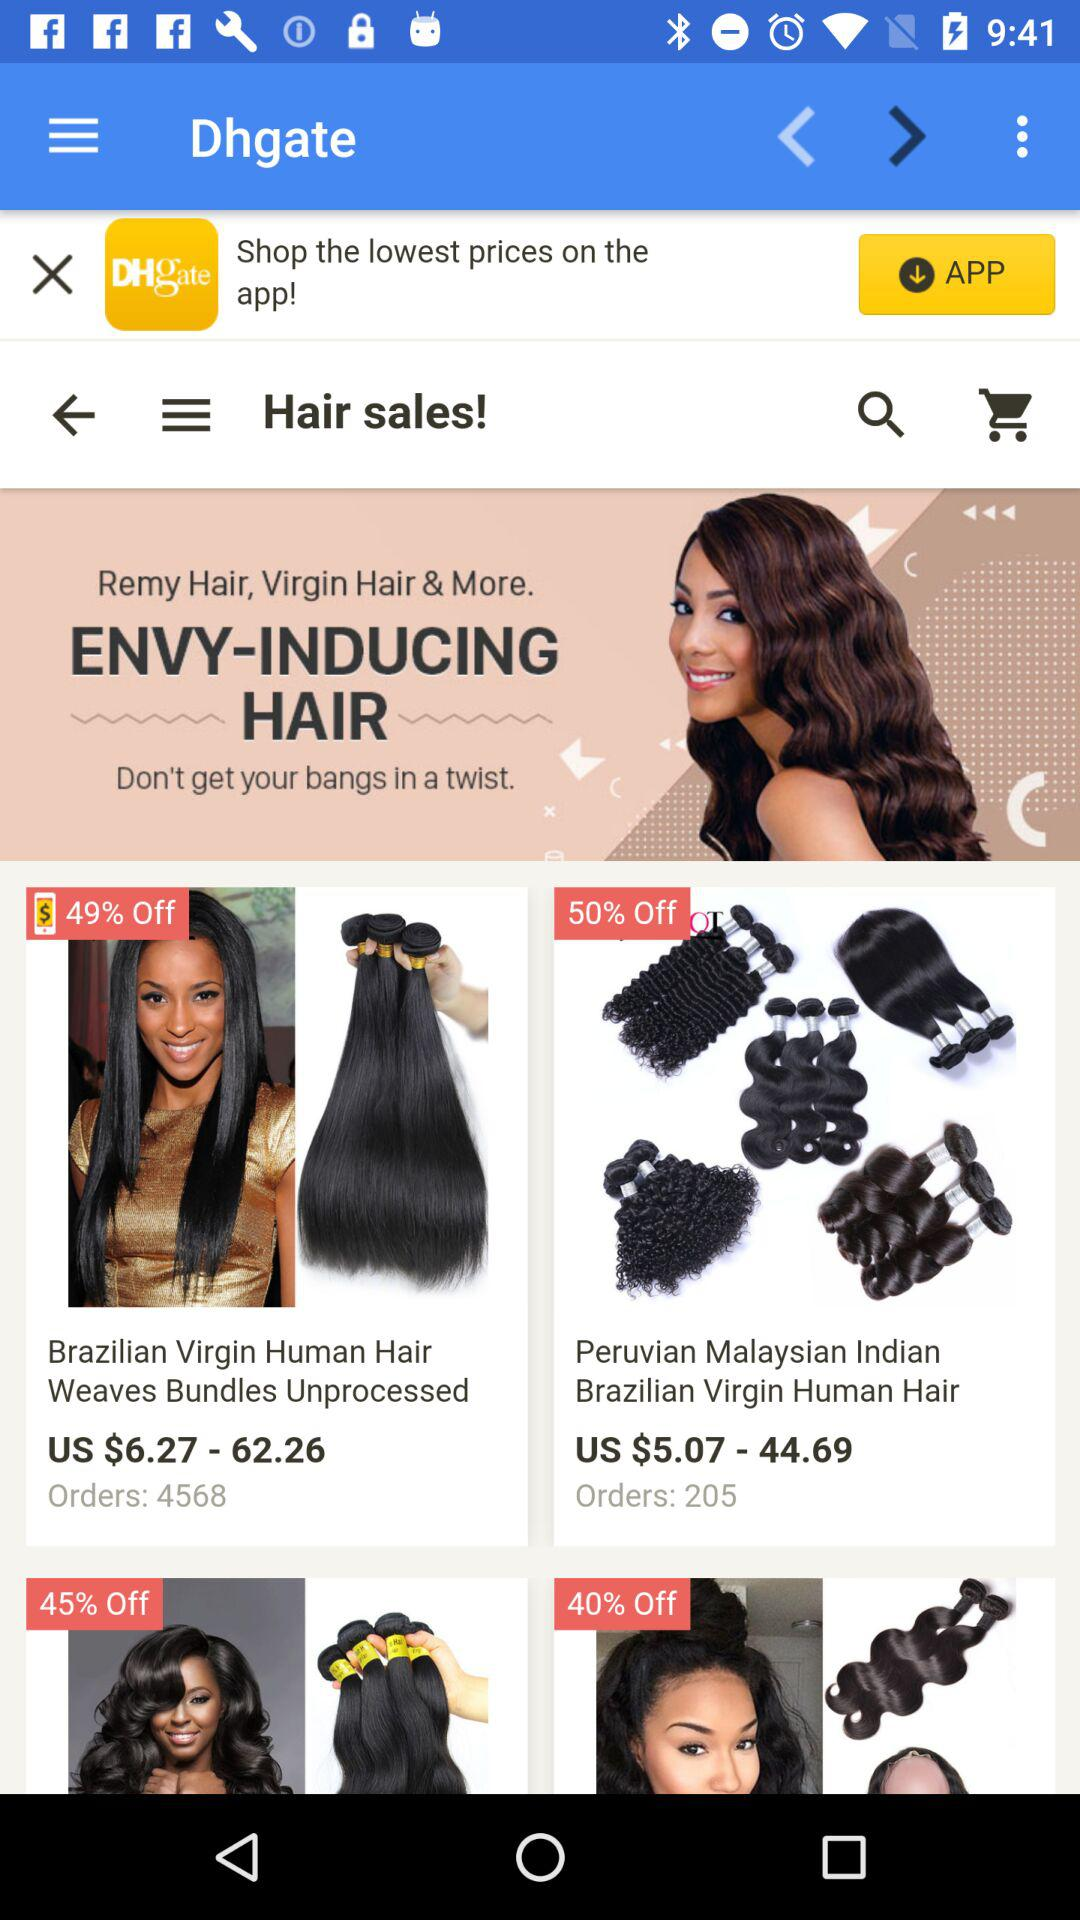What is the price range of Brazilian Virgin Human Hair? The price range is from US $6.27 to $62.26. 